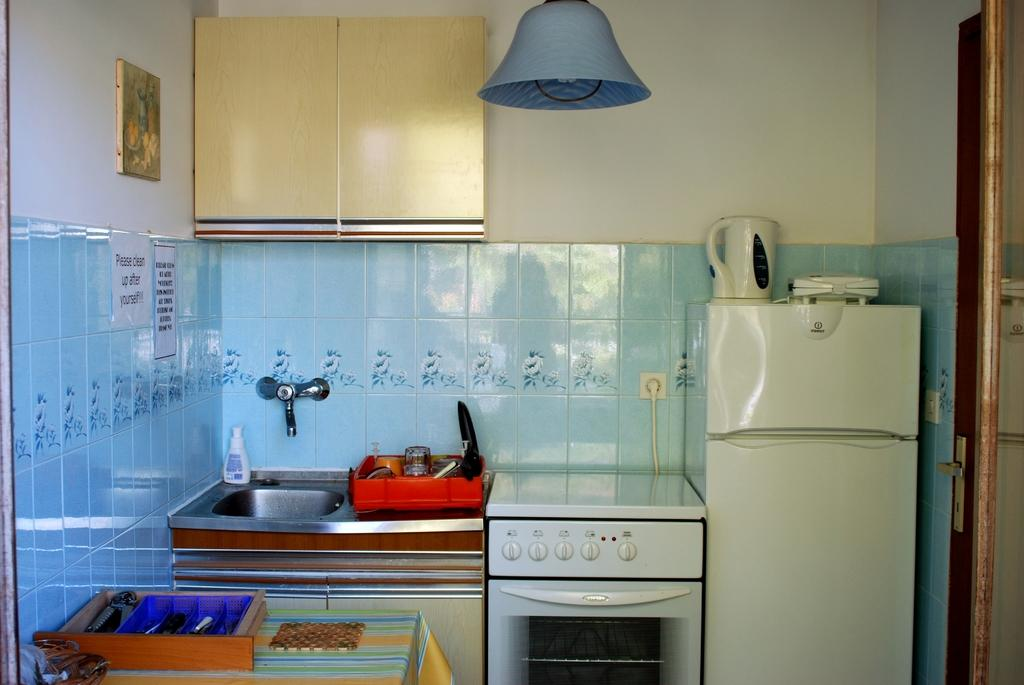<image>
Create a compact narrative representing the image presented. A kitchen has a sign on the wall that says Please Clean up after yourself! 